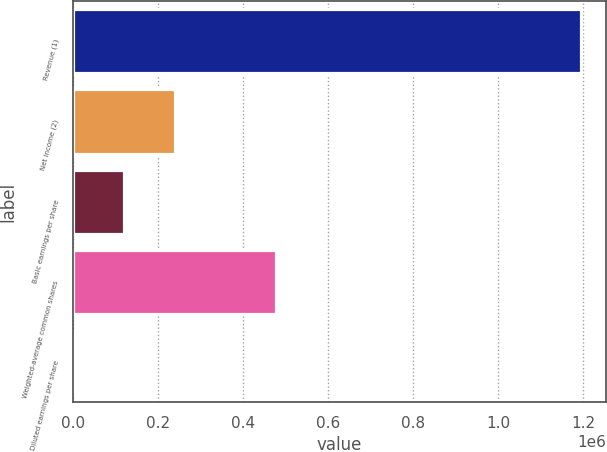Convert chart to OTSL. <chart><loc_0><loc_0><loc_500><loc_500><bar_chart><fcel>Revenue (1)<fcel>Net income (2)<fcel>Basic earnings per share<fcel>Weighted-average common shares<fcel>Diluted earnings per share<nl><fcel>1.19354e+06<fcel>238710<fcel>119355<fcel>477418<fcel>0.88<nl></chart> 